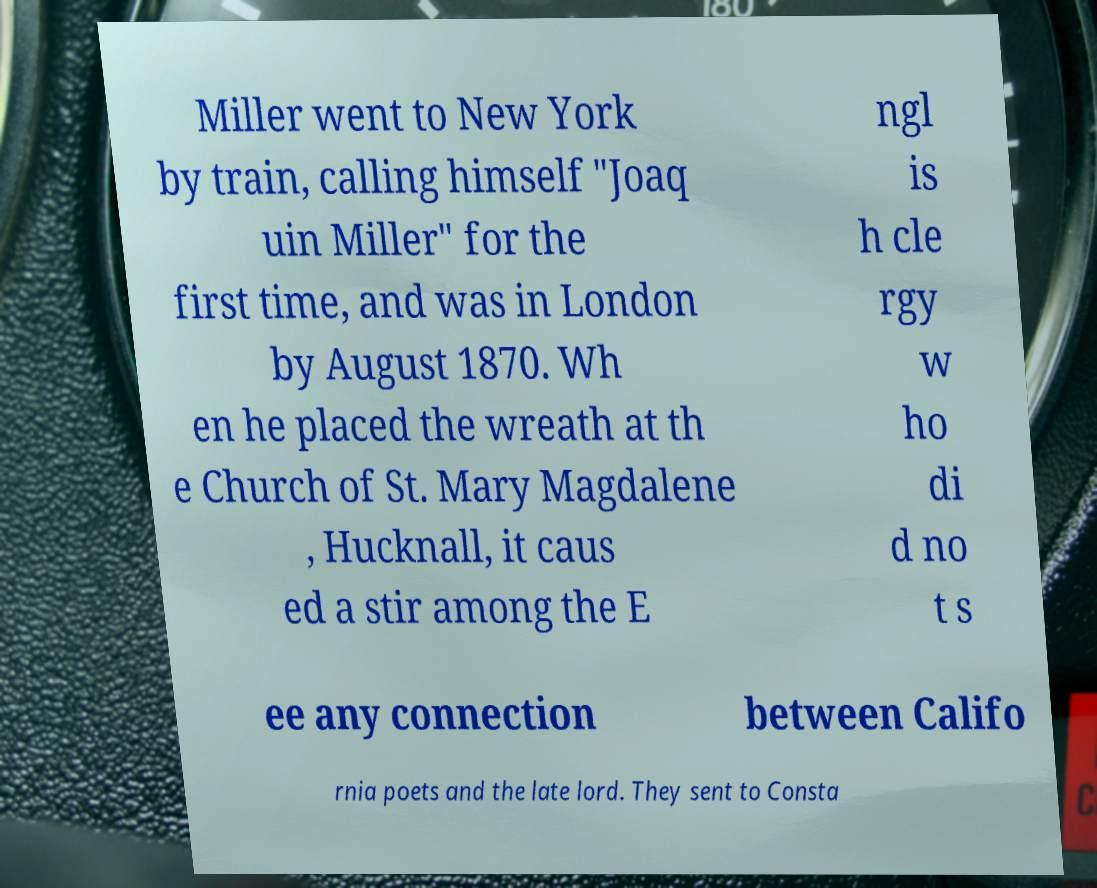Please read and relay the text visible in this image. What does it say? Miller went to New York by train, calling himself "Joaq uin Miller" for the first time, and was in London by August 1870. Wh en he placed the wreath at th e Church of St. Mary Magdalene , Hucknall, it caus ed a stir among the E ngl is h cle rgy w ho di d no t s ee any connection between Califo rnia poets and the late lord. They sent to Consta 